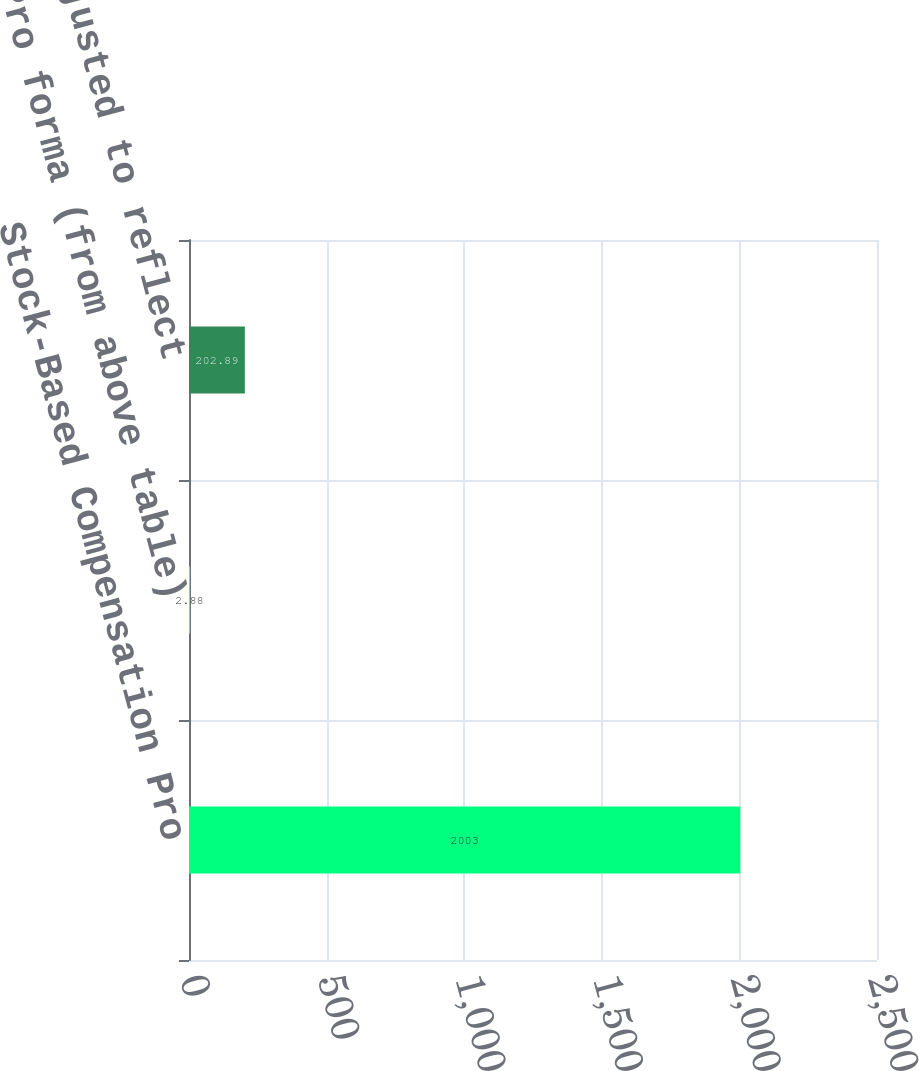<chart> <loc_0><loc_0><loc_500><loc_500><bar_chart><fcel>Stock-Based Compensation Pro<fcel>Pro forma (from above table)<fcel>Pro forma (adjusted to reflect<nl><fcel>2003<fcel>2.88<fcel>202.89<nl></chart> 